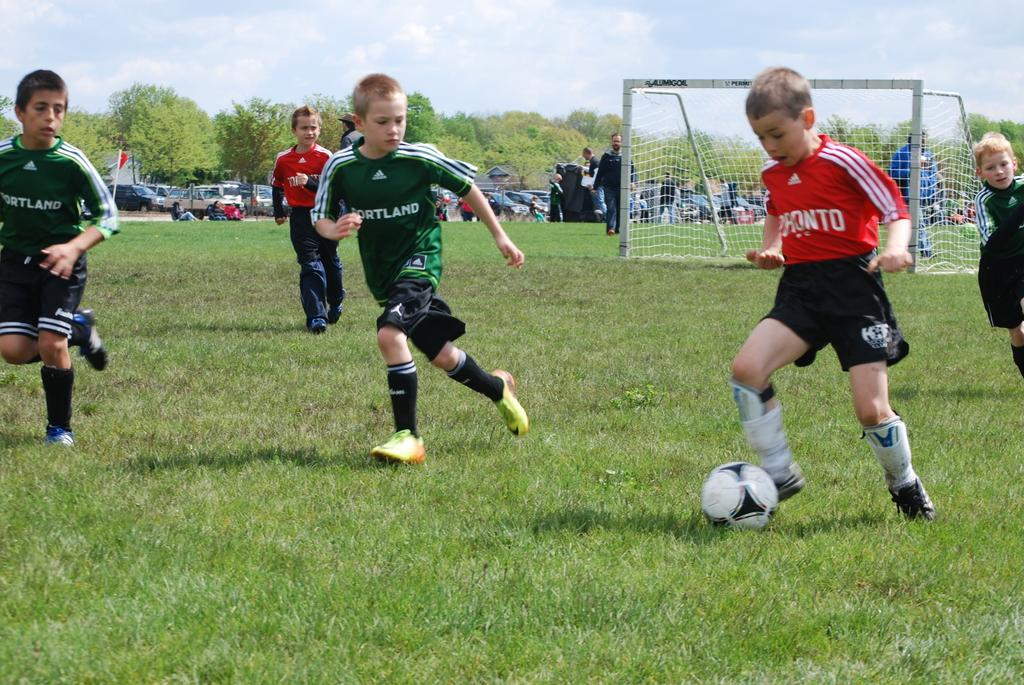What is happening in the image involving a group of people? Some kids are playing a game in the ground. What can be seen in the background of the image? There is a net visible in the background, as well as vehicles and trees. How many twigs are being used by the kids to play the game in the image? There is no mention of twigs being used in the game played by the kids in the image. 